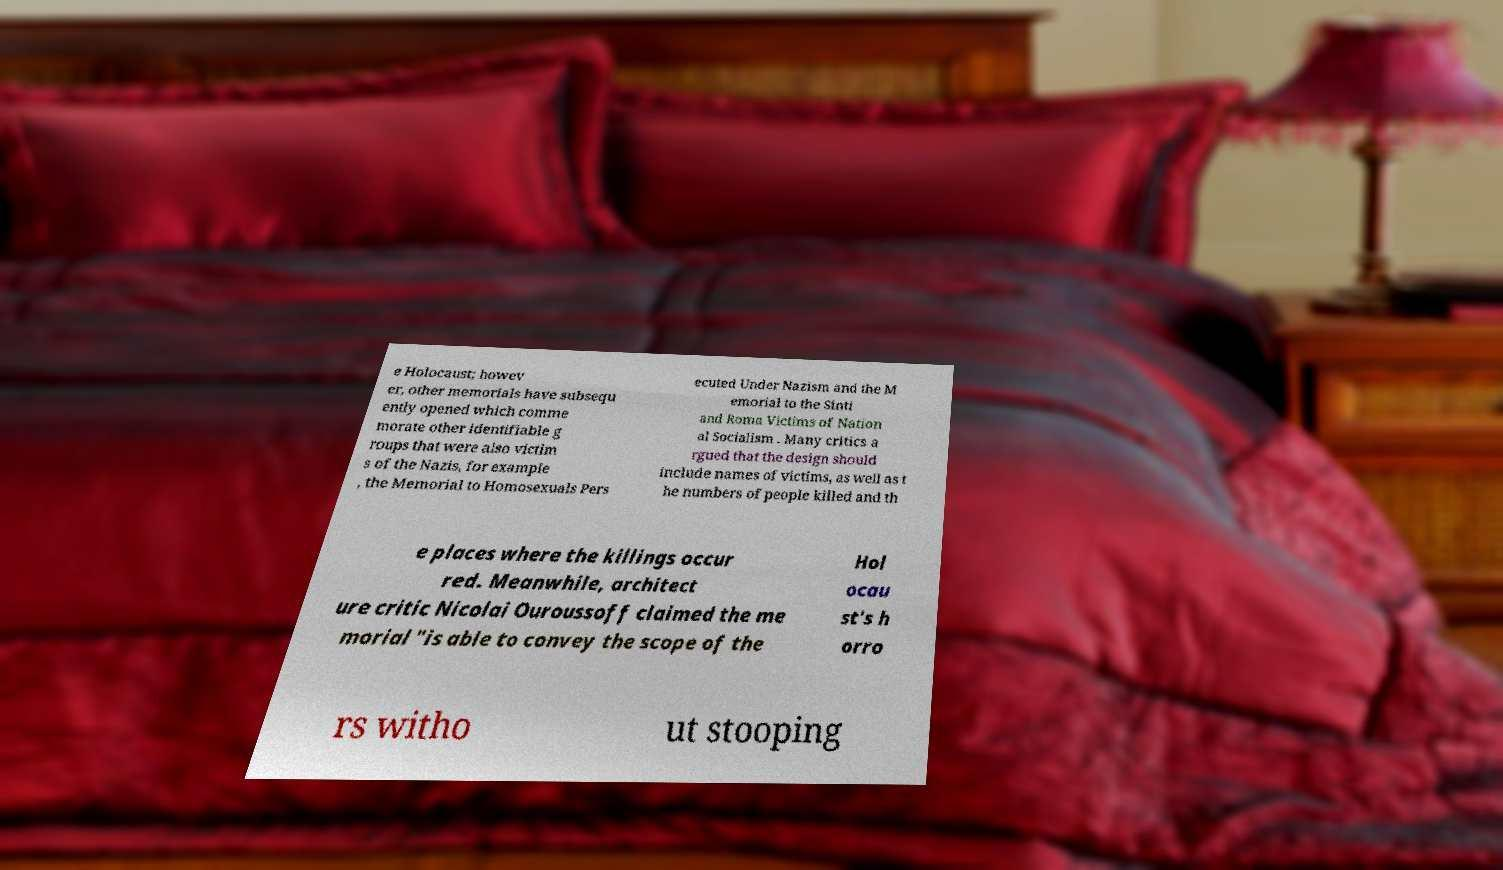For documentation purposes, I need the text within this image transcribed. Could you provide that? e Holocaust; howev er, other memorials have subsequ ently opened which comme morate other identifiable g roups that were also victim s of the Nazis, for example , the Memorial to Homosexuals Pers ecuted Under Nazism and the M emorial to the Sinti and Roma Victims of Nation al Socialism . Many critics a rgued that the design should include names of victims, as well as t he numbers of people killed and th e places where the killings occur red. Meanwhile, architect ure critic Nicolai Ouroussoff claimed the me morial "is able to convey the scope of the Hol ocau st's h orro rs witho ut stooping 